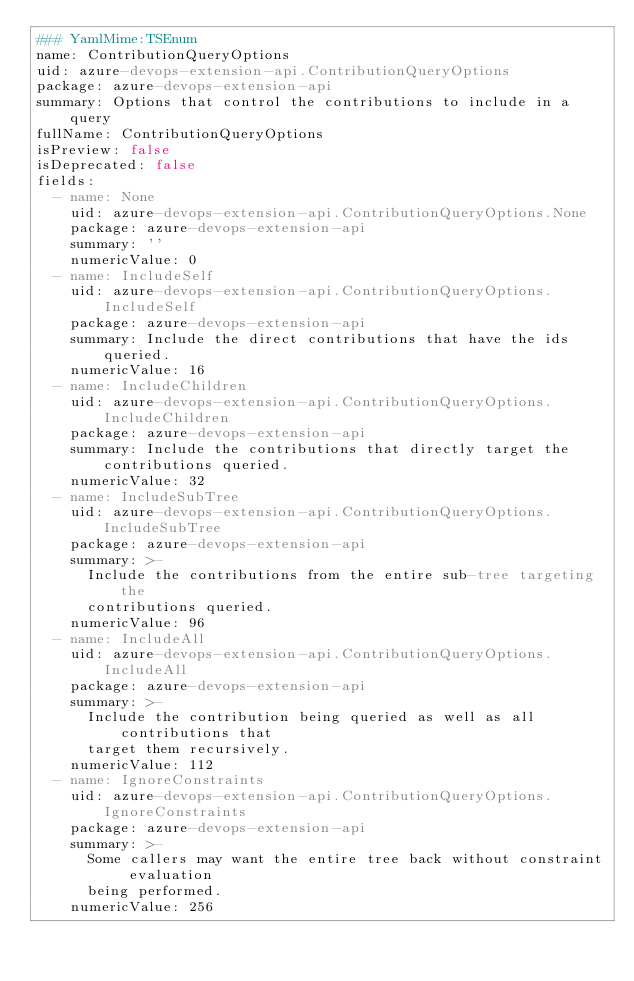<code> <loc_0><loc_0><loc_500><loc_500><_YAML_>### YamlMime:TSEnum
name: ContributionQueryOptions
uid: azure-devops-extension-api.ContributionQueryOptions
package: azure-devops-extension-api
summary: Options that control the contributions to include in a query
fullName: ContributionQueryOptions
isPreview: false
isDeprecated: false
fields:
  - name: None
    uid: azure-devops-extension-api.ContributionQueryOptions.None
    package: azure-devops-extension-api
    summary: ''
    numericValue: 0
  - name: IncludeSelf
    uid: azure-devops-extension-api.ContributionQueryOptions.IncludeSelf
    package: azure-devops-extension-api
    summary: Include the direct contributions that have the ids queried.
    numericValue: 16
  - name: IncludeChildren
    uid: azure-devops-extension-api.ContributionQueryOptions.IncludeChildren
    package: azure-devops-extension-api
    summary: Include the contributions that directly target the contributions queried.
    numericValue: 32
  - name: IncludeSubTree
    uid: azure-devops-extension-api.ContributionQueryOptions.IncludeSubTree
    package: azure-devops-extension-api
    summary: >-
      Include the contributions from the entire sub-tree targeting the
      contributions queried.
    numericValue: 96
  - name: IncludeAll
    uid: azure-devops-extension-api.ContributionQueryOptions.IncludeAll
    package: azure-devops-extension-api
    summary: >-
      Include the contribution being queried as well as all contributions that
      target them recursively.
    numericValue: 112
  - name: IgnoreConstraints
    uid: azure-devops-extension-api.ContributionQueryOptions.IgnoreConstraints
    package: azure-devops-extension-api
    summary: >-
      Some callers may want the entire tree back without constraint evaluation
      being performed.
    numericValue: 256
</code> 